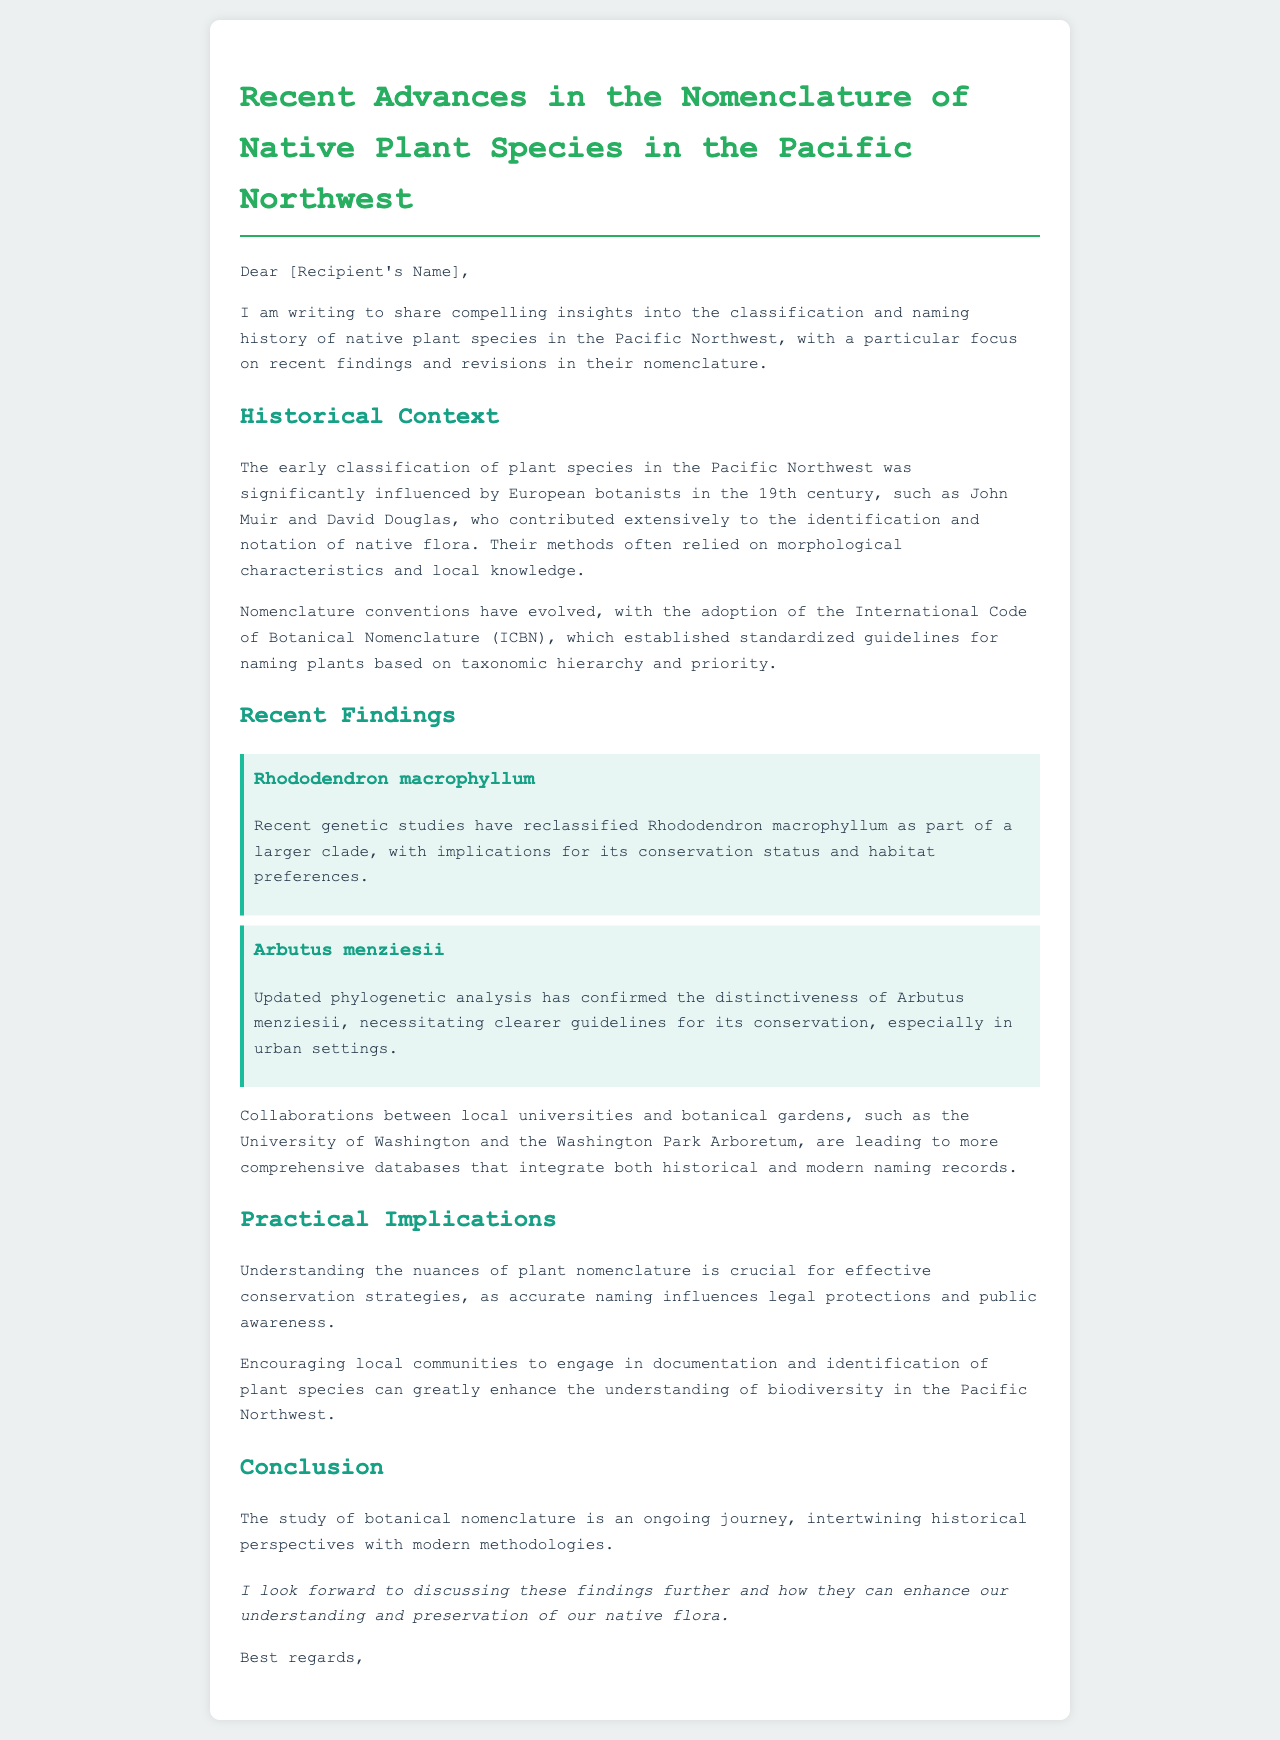What are the names of two botanists mentioned? The document names John Muir and David Douglas as significant contributors to plant classification in the Pacific Northwest.
Answer: John Muir, David Douglas What is the species name of the rhododendron discussed? The letter explicitly mentions Rhododendron macrophyllum as a subject of recent genetic studies that led to its reclassification.
Answer: Rhododendron macrophyllum What classification code is referenced in the document? The document refers to the International Code of Botanical Nomenclature (ICBN) as the guideline for naming plants.
Answer: International Code of Botanical Nomenclature (ICBN) What is the conservation status implication for Arbutus menziesii? The document states that updated phylogenetic analysis has confirmed the distinctiveness of Arbutus menziesii, necessitating clearer guidelines for its conservation.
Answer: Clearer guidelines for conservation How are the recent findings beneficial to biodiversity understanding? These findings encourage local communities to engage in documentation and identification of plant species, enhancing understanding of biodiversity.
Answer: Engagement in documentation and identification What is the main focus of the letter? The central aim of the letter is to share insights into classification and naming history of native plant species in the Pacific Northwest and recent findings.
Answer: Classification and naming history of native plant species 